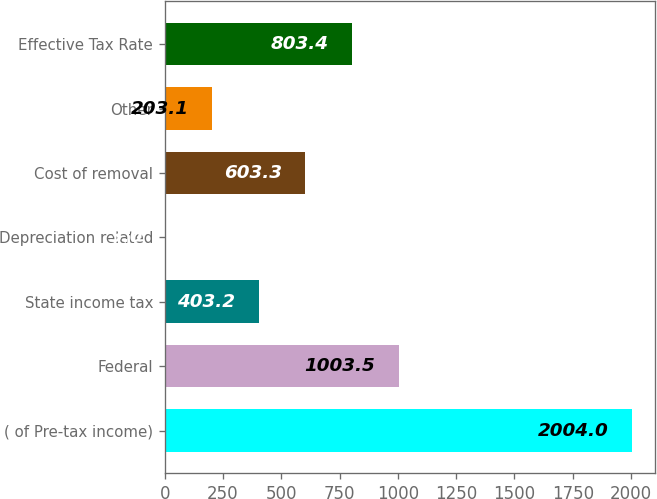Convert chart. <chart><loc_0><loc_0><loc_500><loc_500><bar_chart><fcel>( of Pre-tax income)<fcel>Federal<fcel>State income tax<fcel>Depreciation related<fcel>Cost of removal<fcel>Other<fcel>Effective Tax Rate<nl><fcel>2004<fcel>1003.5<fcel>403.2<fcel>3<fcel>603.3<fcel>203.1<fcel>803.4<nl></chart> 